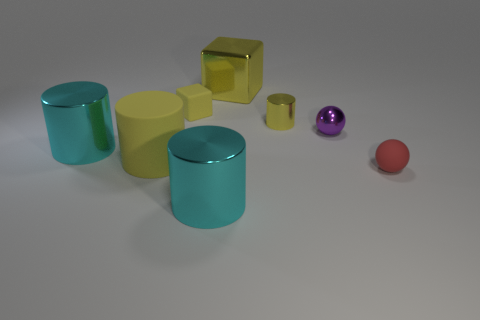Does the big shiny cube have the same color as the matte cylinder?
Offer a terse response. Yes. Is there any other thing that has the same color as the shiny sphere?
Offer a terse response. No. What is the shape of the rubber object that is the same color as the small matte cube?
Your answer should be very brief. Cylinder. Do the yellow cylinder that is on the right side of the big yellow rubber object and the cube that is to the left of the large cube have the same material?
Make the answer very short. No. The cylinder behind the small ball on the left side of the small red matte object is made of what material?
Provide a succinct answer. Metal. What size is the ball in front of the yellow cylinder that is in front of the yellow cylinder to the right of the large yellow metallic object?
Provide a succinct answer. Small. Is the red matte thing the same size as the rubber cube?
Provide a short and direct response. Yes. There is a big metal object on the left side of the big rubber cylinder; does it have the same shape as the yellow rubber object behind the tiny yellow metallic cylinder?
Provide a short and direct response. No. Are there any small rubber cubes to the left of the ball that is behind the large matte cylinder?
Your response must be concise. Yes. Is there a small red metal sphere?
Your answer should be compact. No. 